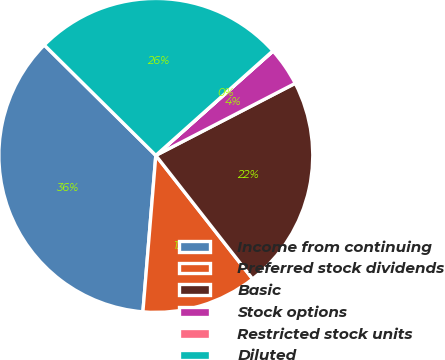Convert chart. <chart><loc_0><loc_0><loc_500><loc_500><pie_chart><fcel>Income from continuing<fcel>Preferred stock dividends<fcel>Basic<fcel>Stock options<fcel>Restricted stock units<fcel>Diluted<nl><fcel>36.11%<fcel>11.89%<fcel>22.02%<fcel>3.98%<fcel>0.03%<fcel>25.98%<nl></chart> 